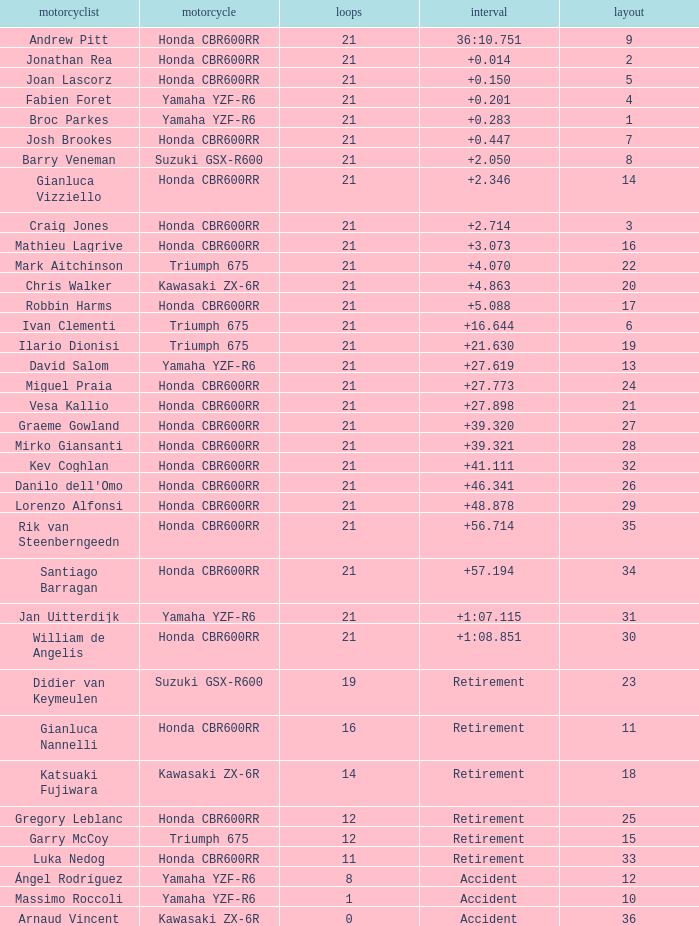What driver had the highest grid position with a time of +0.283? 1.0. 